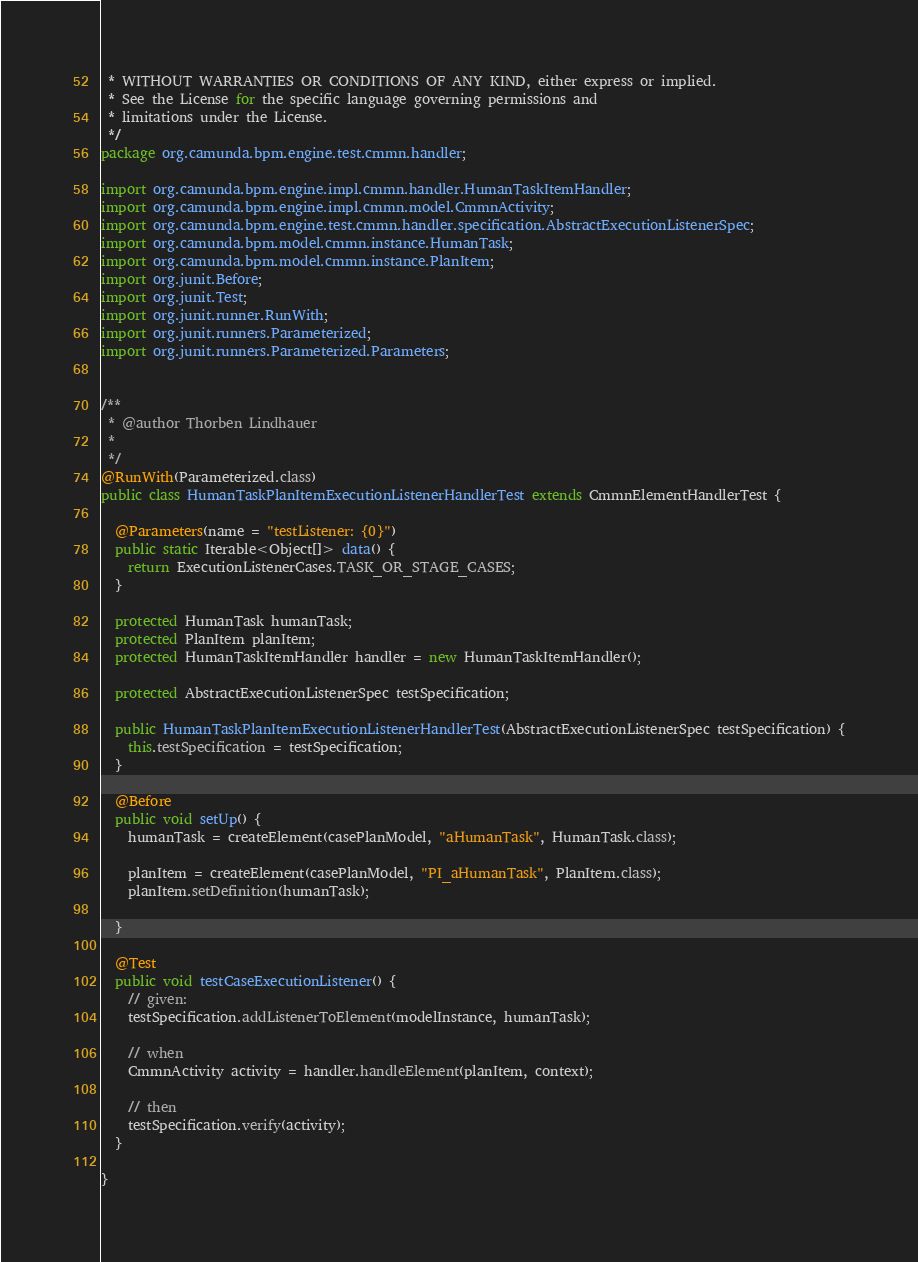Convert code to text. <code><loc_0><loc_0><loc_500><loc_500><_Java_> * WITHOUT WARRANTIES OR CONDITIONS OF ANY KIND, either express or implied.
 * See the License for the specific language governing permissions and
 * limitations under the License.
 */
package org.camunda.bpm.engine.test.cmmn.handler;

import org.camunda.bpm.engine.impl.cmmn.handler.HumanTaskItemHandler;
import org.camunda.bpm.engine.impl.cmmn.model.CmmnActivity;
import org.camunda.bpm.engine.test.cmmn.handler.specification.AbstractExecutionListenerSpec;
import org.camunda.bpm.model.cmmn.instance.HumanTask;
import org.camunda.bpm.model.cmmn.instance.PlanItem;
import org.junit.Before;
import org.junit.Test;
import org.junit.runner.RunWith;
import org.junit.runners.Parameterized;
import org.junit.runners.Parameterized.Parameters;


/**
 * @author Thorben Lindhauer
 *
 */
@RunWith(Parameterized.class)
public class HumanTaskPlanItemExecutionListenerHandlerTest extends CmmnElementHandlerTest {

  @Parameters(name = "testListener: {0}")
  public static Iterable<Object[]> data() {
    return ExecutionListenerCases.TASK_OR_STAGE_CASES;
  }

  protected HumanTask humanTask;
  protected PlanItem planItem;
  protected HumanTaskItemHandler handler = new HumanTaskItemHandler();

  protected AbstractExecutionListenerSpec testSpecification;

  public HumanTaskPlanItemExecutionListenerHandlerTest(AbstractExecutionListenerSpec testSpecification) {
    this.testSpecification = testSpecification;
  }

  @Before
  public void setUp() {
    humanTask = createElement(casePlanModel, "aHumanTask", HumanTask.class);

    planItem = createElement(casePlanModel, "PI_aHumanTask", PlanItem.class);
    planItem.setDefinition(humanTask);

  }

  @Test
  public void testCaseExecutionListener() {
    // given:
    testSpecification.addListenerToElement(modelInstance, humanTask);

    // when
    CmmnActivity activity = handler.handleElement(planItem, context);

    // then
    testSpecification.verify(activity);
  }

}
</code> 